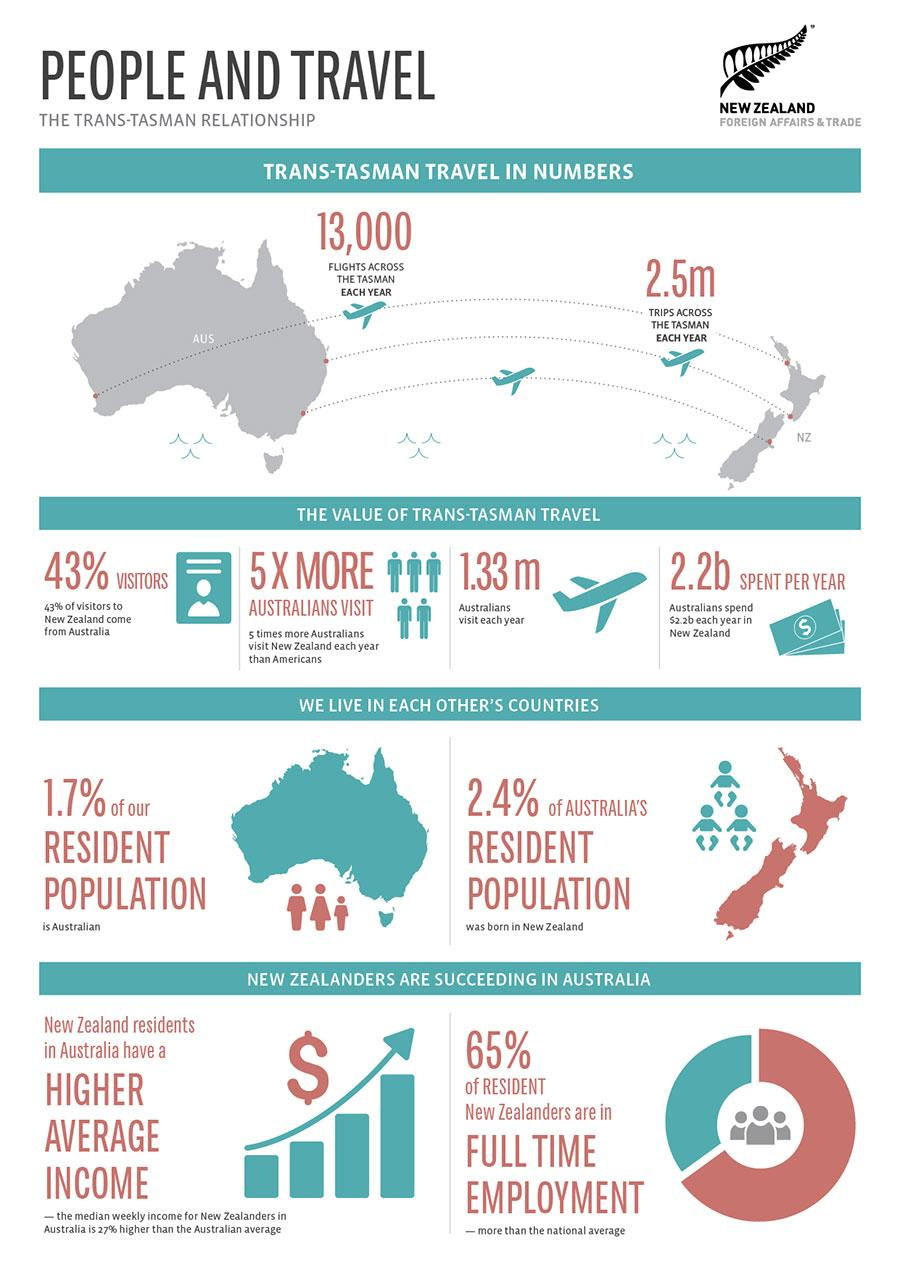Indicate a few pertinent items in this graphic. In New Zealand, approximately 65% of residents are currently in full-time employment. According to the latest statistics, approximately 1.7% of New Zealand's resident population currently resides in Australia. According to recent estimates, the annual spent by Australians in New Zealand is approximately 2.2 billion dollars. According to data, 2.4% of Australia's resident population were born in New Zealand. Approximately 1.33 million Australians visit New Zealand annually. 